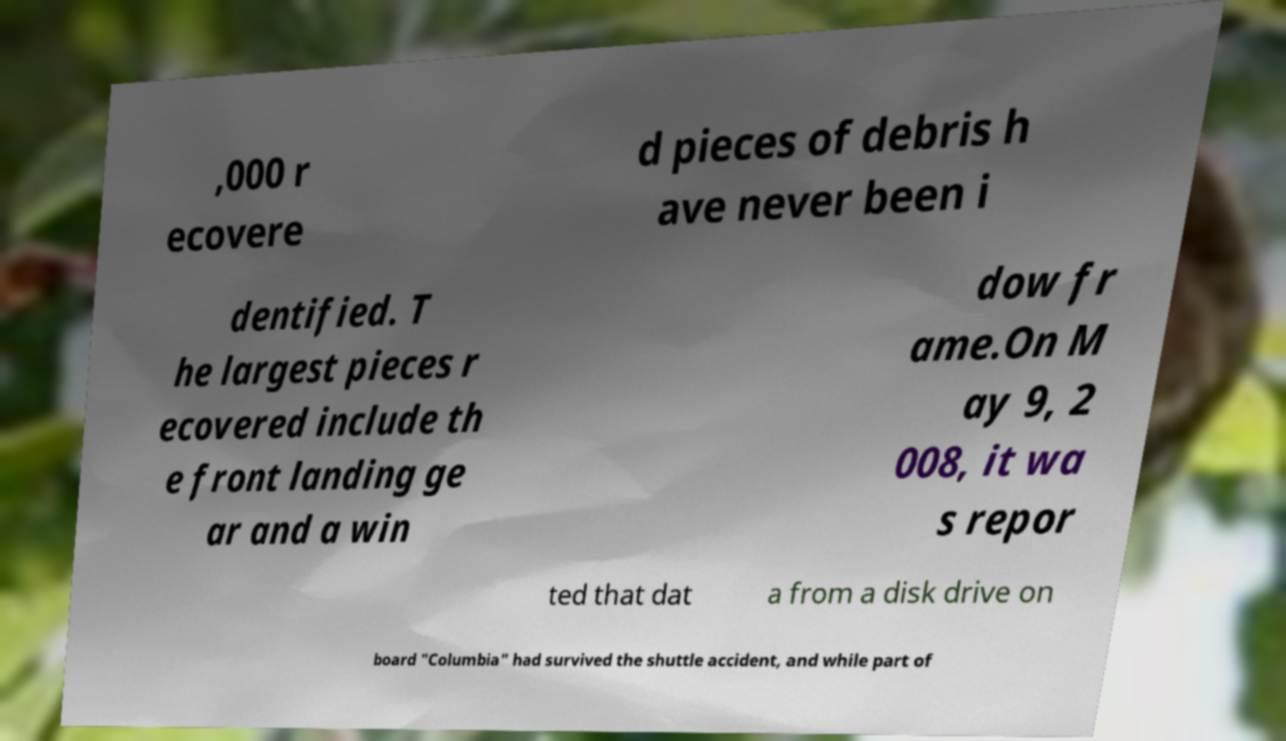What messages or text are displayed in this image? I need them in a readable, typed format. ,000 r ecovere d pieces of debris h ave never been i dentified. T he largest pieces r ecovered include th e front landing ge ar and a win dow fr ame.On M ay 9, 2 008, it wa s repor ted that dat a from a disk drive on board "Columbia" had survived the shuttle accident, and while part of 